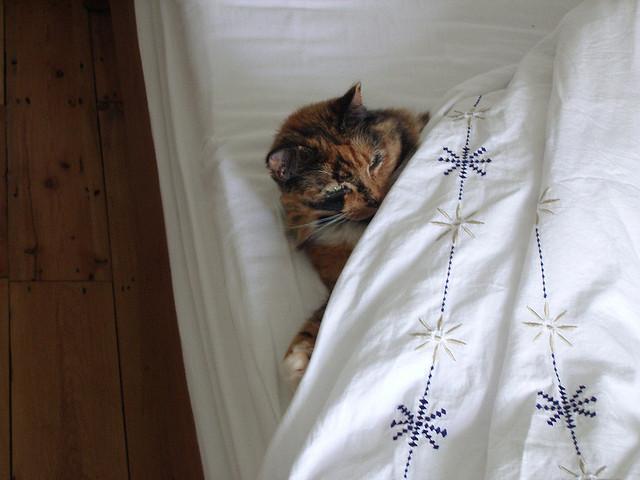How many birds are there in the picture?
Give a very brief answer. 0. 